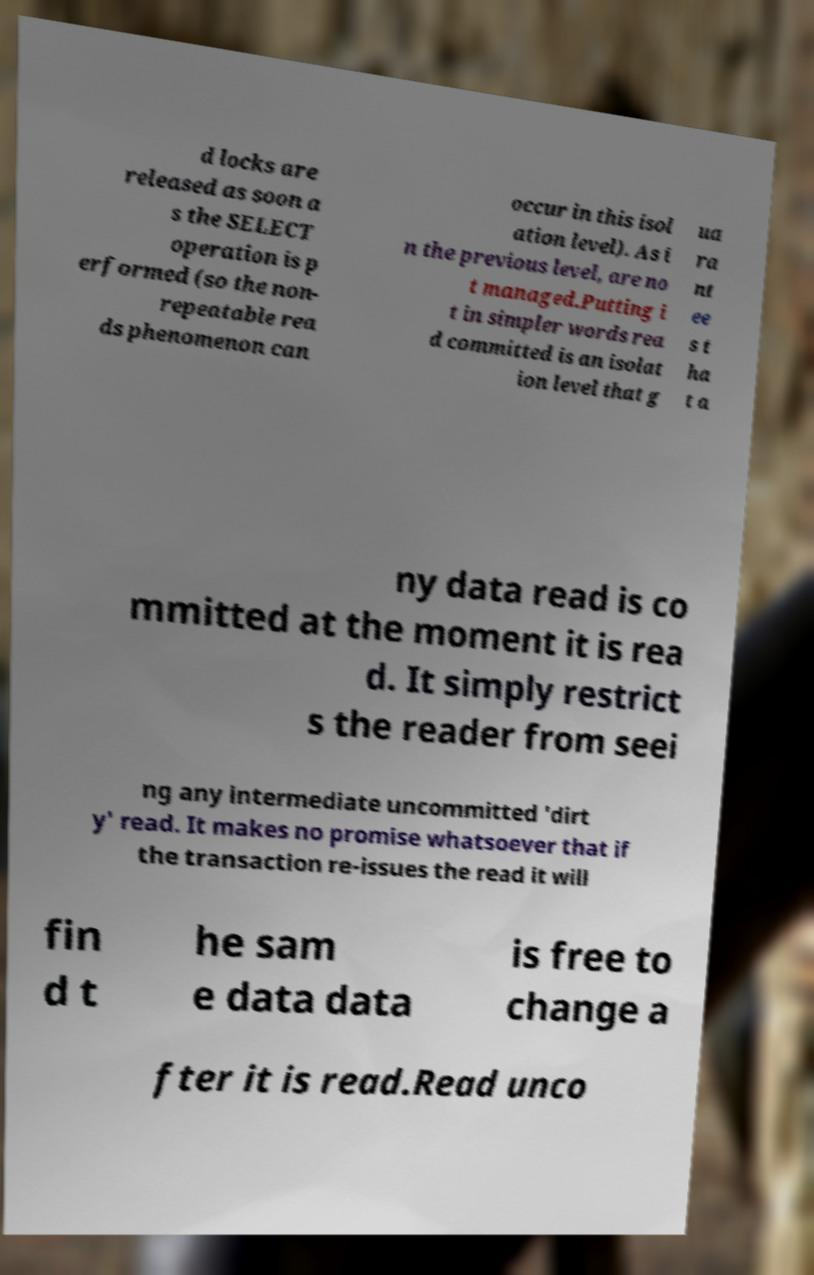Can you read and provide the text displayed in the image?This photo seems to have some interesting text. Can you extract and type it out for me? d locks are released as soon a s the SELECT operation is p erformed (so the non- repeatable rea ds phenomenon can occur in this isol ation level). As i n the previous level, are no t managed.Putting i t in simpler words rea d committed is an isolat ion level that g ua ra nt ee s t ha t a ny data read is co mmitted at the moment it is rea d. It simply restrict s the reader from seei ng any intermediate uncommitted 'dirt y' read. It makes no promise whatsoever that if the transaction re-issues the read it will fin d t he sam e data data is free to change a fter it is read.Read unco 